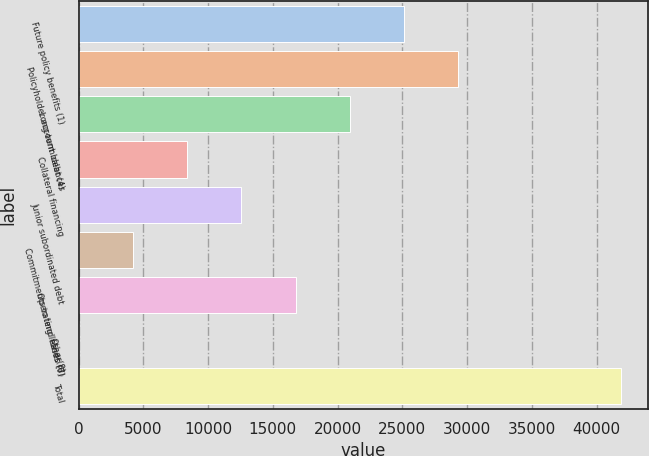Convert chart to OTSL. <chart><loc_0><loc_0><loc_500><loc_500><bar_chart><fcel>Future policy benefits (1)<fcel>Policyholder account balances<fcel>Long-term debt (4)<fcel>Collateral financing<fcel>Junior subordinated debt<fcel>Commitments to lend funds (6)<fcel>Operating leases (7)<fcel>Other(8)<fcel>Total<nl><fcel>25125.6<fcel>29312.2<fcel>20939<fcel>8379.2<fcel>12565.8<fcel>4192.6<fcel>16752.4<fcel>6<fcel>41872<nl></chart> 